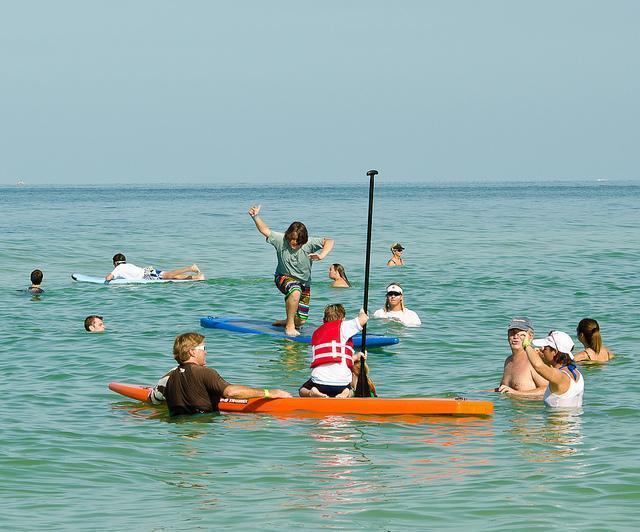How many people are in this photo?
Give a very brief answer. 12. How many people are there?
Give a very brief answer. 5. 